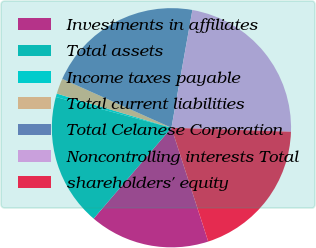<chart> <loc_0><loc_0><loc_500><loc_500><pie_chart><fcel>Investments in affiliates<fcel>Total assets<fcel>Income taxes payable<fcel>Total current liabilities<fcel>Total Celanese Corporation<fcel>Noncontrolling interests Total<fcel>shareholders' equity<nl><fcel>16.25%<fcel>17.87%<fcel>0.47%<fcel>2.09%<fcel>21.11%<fcel>22.73%<fcel>19.49%<nl></chart> 